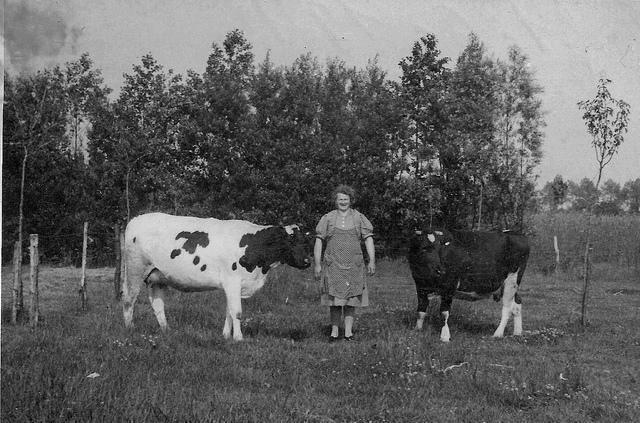What is the woman's orientation in relation to the cows?
Indicate the correct choice and explain in the format: 'Answer: answer
Rationale: rationale.'
Options: In between, behind, in front, below. Answer: in between.
Rationale: There is a cow on each side of the woman. 